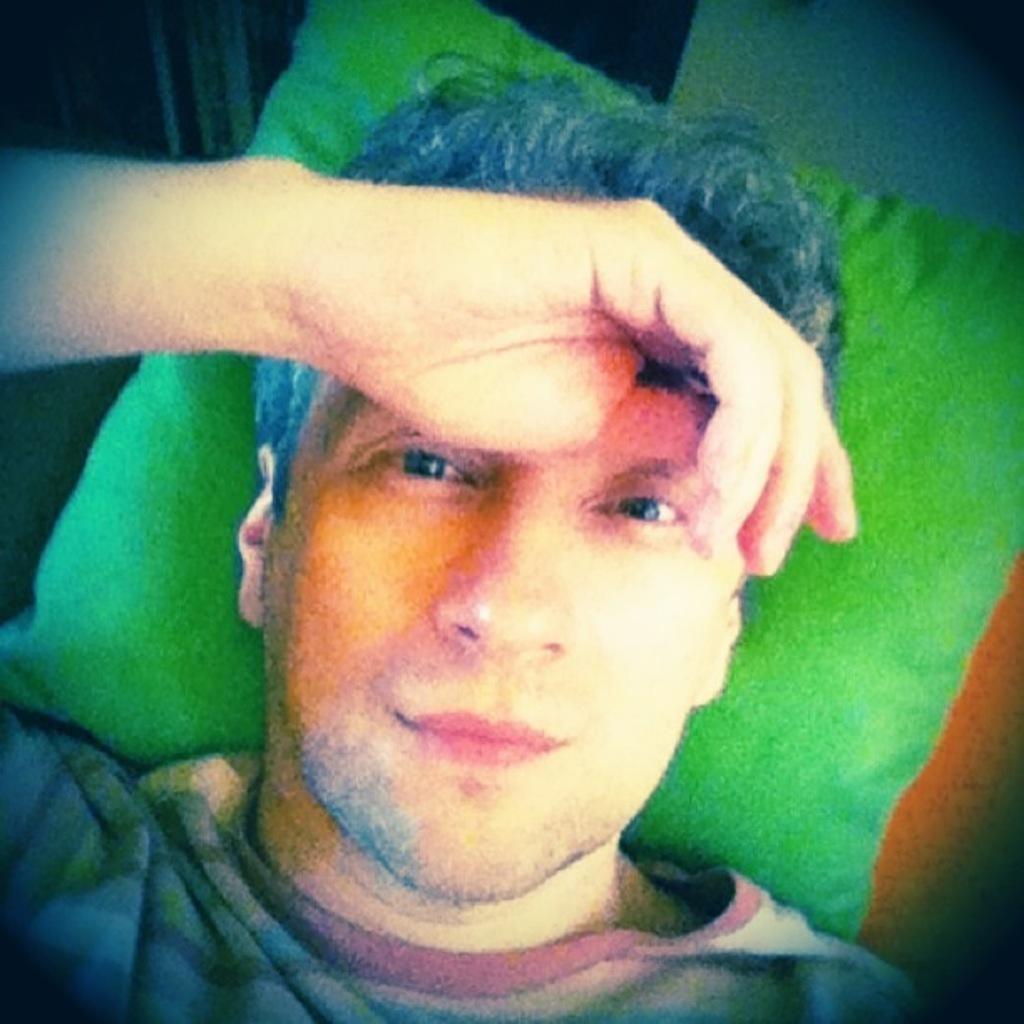What is the main subject of the image? There is a man in the image. What is the man wearing? The man is wearing a t-shirt. What is the man's position in the image? The man is lying on the bed. What color is the pillow behind the man? The pillow behind the man is green. Can you describe the background of the image? There might be a wall visible in the top right corner of the image. What type of committee is meeting in the image? There is no committee meeting in the image; it features a man lying on a bed. How many snakes can be seen slithering on the bed in the image? There are no snakes present in the image; it only shows a man lying on a bed with a green pillow. 